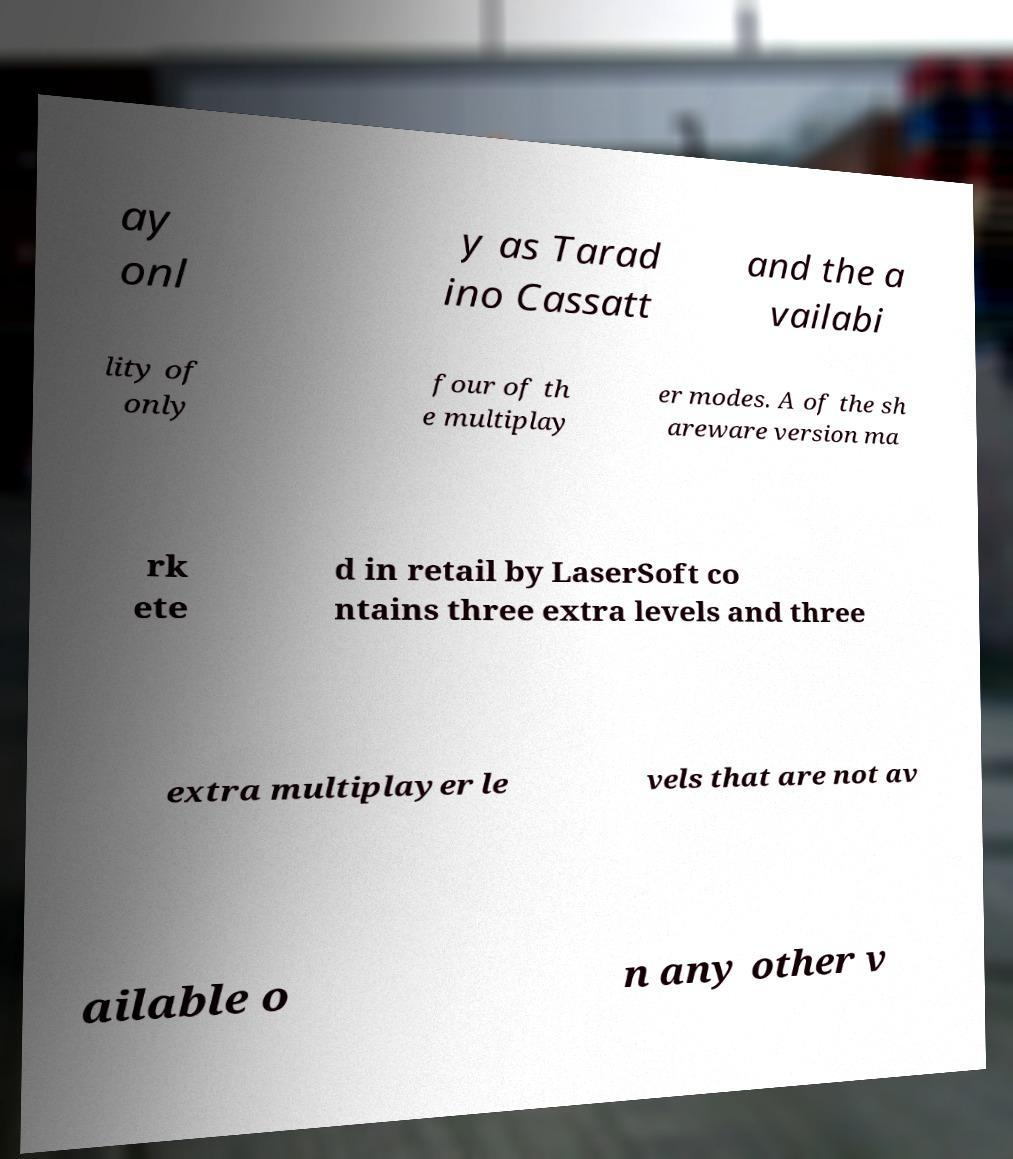Please read and relay the text visible in this image. What does it say? ay onl y as Tarad ino Cassatt and the a vailabi lity of only four of th e multiplay er modes. A of the sh areware version ma rk ete d in retail by LaserSoft co ntains three extra levels and three extra multiplayer le vels that are not av ailable o n any other v 